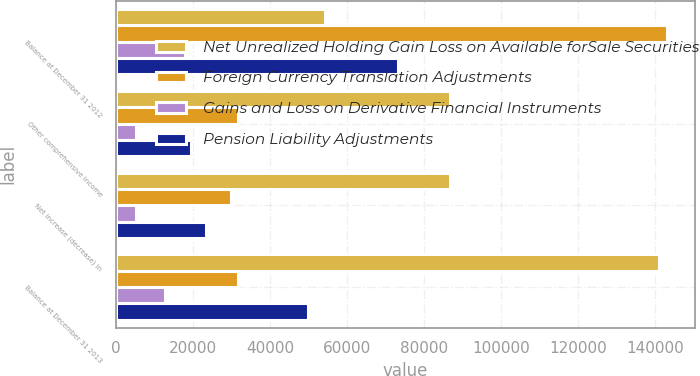Convert chart. <chart><loc_0><loc_0><loc_500><loc_500><stacked_bar_chart><ecel><fcel>Balance at December 31 2012<fcel>Other comprehensive income<fcel>Net increase (decrease) in<fcel>Balance at December 31 2013<nl><fcel>Net Unrealized Holding Gain Loss on Available forSale Securities<fcel>54302<fcel>86690<fcel>86690<fcel>140992<nl><fcel>Foreign Currency Translation Adjustments<fcel>143142<fcel>31687<fcel>29725<fcel>31687<nl><fcel>Gains and Loss on Derivative Financial Instruments<fcel>17822<fcel>5093<fcel>5093<fcel>12729<nl><fcel>Pension Liability Adjustments<fcel>73182<fcel>19478<fcel>23266<fcel>49916<nl></chart> 